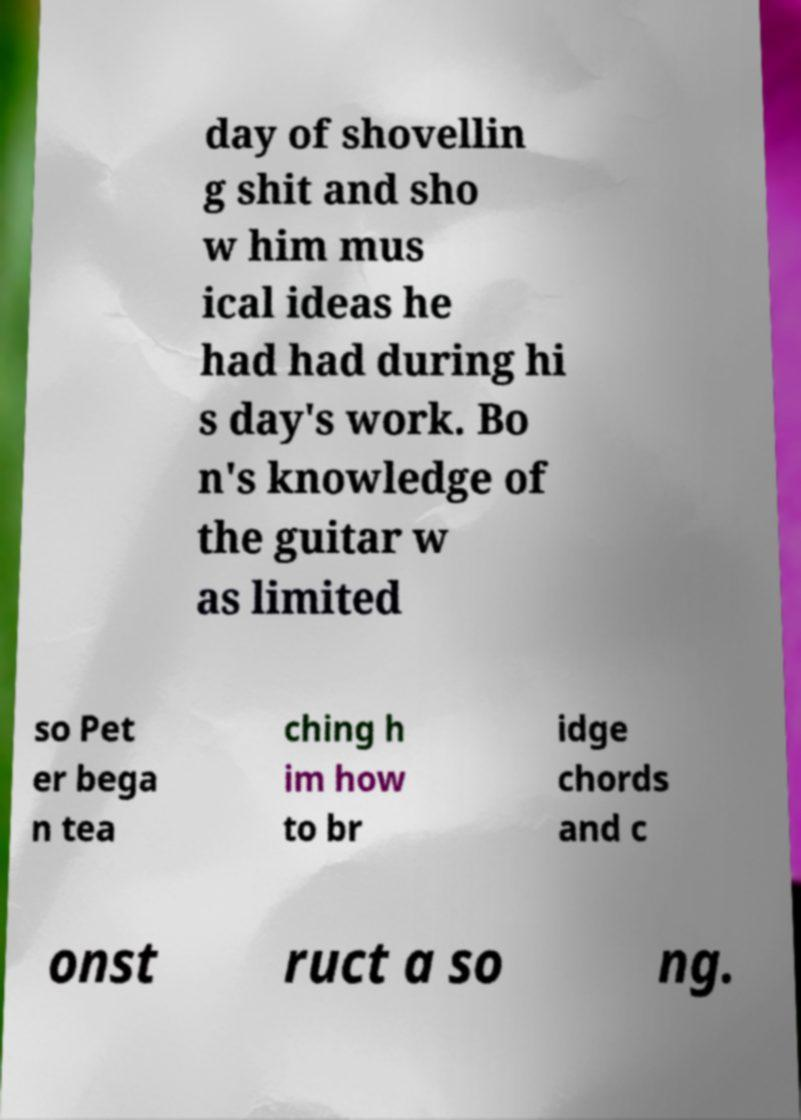Please identify and transcribe the text found in this image. day of shovellin g shit and sho w him mus ical ideas he had had during hi s day's work. Bo n's knowledge of the guitar w as limited so Pet er bega n tea ching h im how to br idge chords and c onst ruct a so ng. 